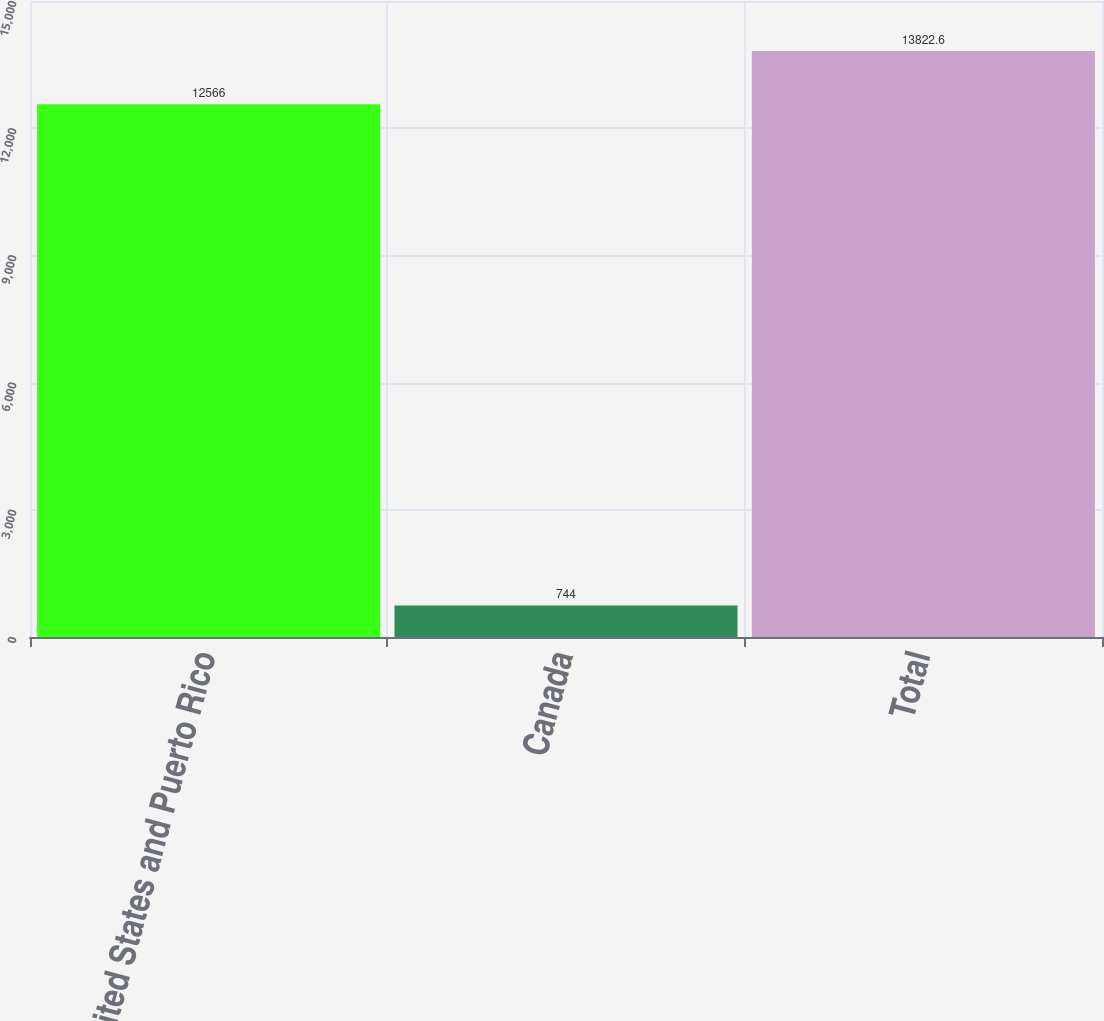Convert chart. <chart><loc_0><loc_0><loc_500><loc_500><bar_chart><fcel>United States and Puerto Rico<fcel>Canada<fcel>Total<nl><fcel>12566<fcel>744<fcel>13822.6<nl></chart> 